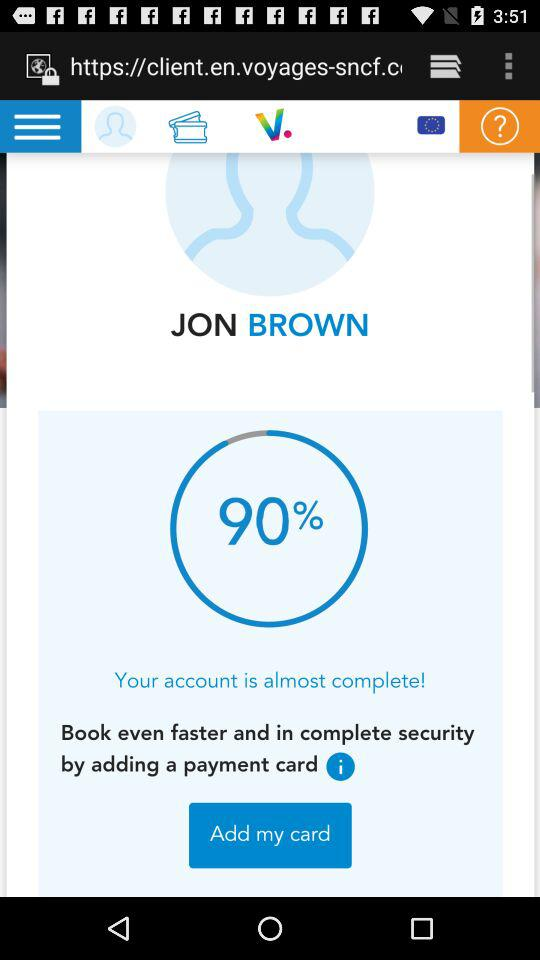How many months are represented in the text?
Answer the question using a single word or phrase. 3 